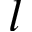Convert formula to latex. <formula><loc_0><loc_0><loc_500><loc_500>l</formula> 